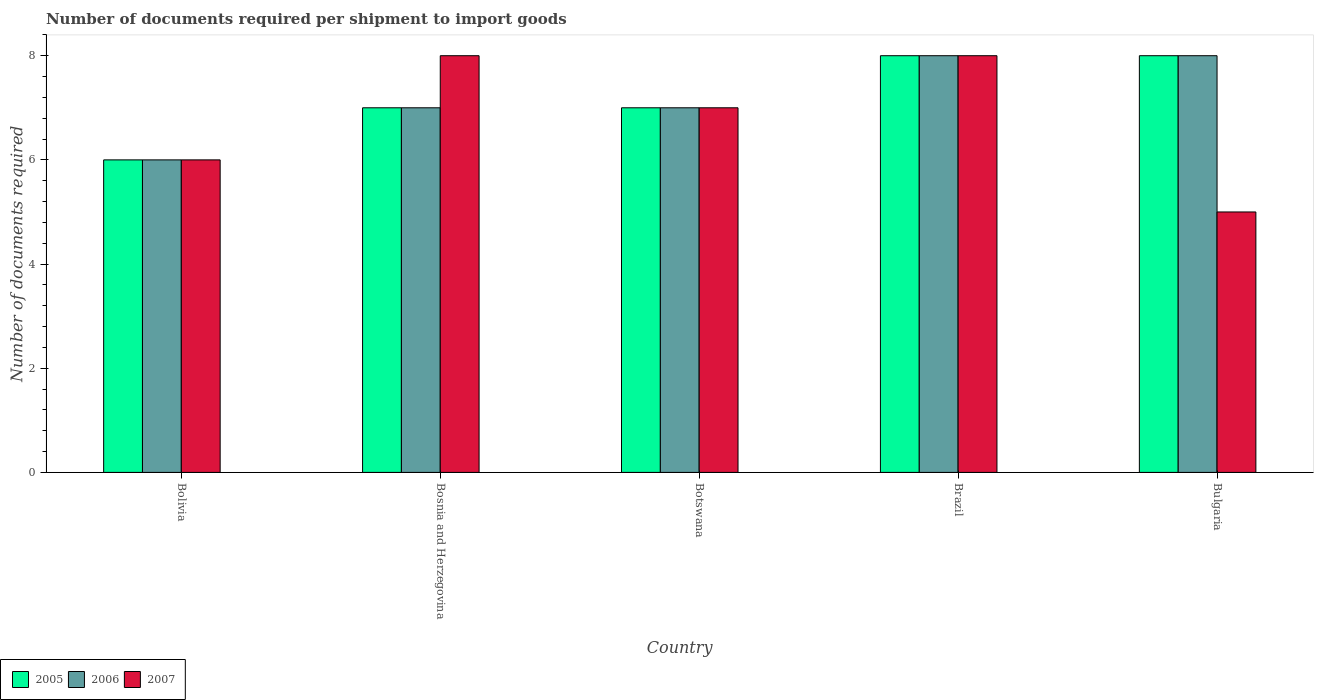How many groups of bars are there?
Keep it short and to the point. 5. Are the number of bars per tick equal to the number of legend labels?
Make the answer very short. Yes. Are the number of bars on each tick of the X-axis equal?
Offer a terse response. Yes. How many bars are there on the 3rd tick from the left?
Ensure brevity in your answer.  3. How many bars are there on the 2nd tick from the right?
Make the answer very short. 3. What is the label of the 1st group of bars from the left?
Offer a very short reply. Bolivia. Across all countries, what is the maximum number of documents required per shipment to import goods in 2005?
Keep it short and to the point. 8. In which country was the number of documents required per shipment to import goods in 2007 minimum?
Ensure brevity in your answer.  Bulgaria. What is the total number of documents required per shipment to import goods in 2006 in the graph?
Your answer should be compact. 36. What is the average number of documents required per shipment to import goods in 2007 per country?
Provide a short and direct response. 6.8. What is the difference between the number of documents required per shipment to import goods of/in 2007 and number of documents required per shipment to import goods of/in 2005 in Brazil?
Provide a succinct answer. 0. In how many countries, is the number of documents required per shipment to import goods in 2006 greater than 2?
Make the answer very short. 5. What is the ratio of the number of documents required per shipment to import goods in 2006 in Bolivia to that in Brazil?
Ensure brevity in your answer.  0.75. Is the sum of the number of documents required per shipment to import goods in 2006 in Brazil and Bulgaria greater than the maximum number of documents required per shipment to import goods in 2005 across all countries?
Your answer should be very brief. Yes. Are all the bars in the graph horizontal?
Provide a succinct answer. No. Does the graph contain any zero values?
Provide a succinct answer. No. What is the title of the graph?
Keep it short and to the point. Number of documents required per shipment to import goods. What is the label or title of the Y-axis?
Your response must be concise. Number of documents required. What is the Number of documents required in 2005 in Bolivia?
Provide a short and direct response. 6. What is the Number of documents required of 2006 in Bolivia?
Offer a terse response. 6. What is the Number of documents required in 2007 in Bolivia?
Make the answer very short. 6. What is the Number of documents required in 2005 in Bosnia and Herzegovina?
Make the answer very short. 7. What is the Number of documents required in 2007 in Bosnia and Herzegovina?
Keep it short and to the point. 8. What is the Number of documents required in 2005 in Botswana?
Make the answer very short. 7. What is the Number of documents required in 2006 in Botswana?
Ensure brevity in your answer.  7. What is the Number of documents required in 2005 in Brazil?
Your response must be concise. 8. What is the Number of documents required in 2007 in Brazil?
Provide a short and direct response. 8. Across all countries, what is the maximum Number of documents required of 2005?
Offer a very short reply. 8. Across all countries, what is the maximum Number of documents required in 2007?
Keep it short and to the point. 8. Across all countries, what is the minimum Number of documents required in 2005?
Give a very brief answer. 6. Across all countries, what is the minimum Number of documents required of 2006?
Ensure brevity in your answer.  6. What is the total Number of documents required of 2005 in the graph?
Give a very brief answer. 36. What is the total Number of documents required in 2007 in the graph?
Your answer should be very brief. 34. What is the difference between the Number of documents required in 2005 in Bolivia and that in Bosnia and Herzegovina?
Your answer should be very brief. -1. What is the difference between the Number of documents required in 2007 in Bolivia and that in Bosnia and Herzegovina?
Make the answer very short. -2. What is the difference between the Number of documents required in 2005 in Bolivia and that in Botswana?
Your answer should be very brief. -1. What is the difference between the Number of documents required in 2006 in Bolivia and that in Botswana?
Offer a terse response. -1. What is the difference between the Number of documents required in 2006 in Bolivia and that in Brazil?
Keep it short and to the point. -2. What is the difference between the Number of documents required of 2007 in Bolivia and that in Brazil?
Make the answer very short. -2. What is the difference between the Number of documents required in 2006 in Bolivia and that in Bulgaria?
Your answer should be very brief. -2. What is the difference between the Number of documents required in 2007 in Bolivia and that in Bulgaria?
Your answer should be compact. 1. What is the difference between the Number of documents required of 2005 in Bosnia and Herzegovina and that in Botswana?
Keep it short and to the point. 0. What is the difference between the Number of documents required of 2006 in Bosnia and Herzegovina and that in Brazil?
Offer a terse response. -1. What is the difference between the Number of documents required in 2007 in Bosnia and Herzegovina and that in Brazil?
Provide a short and direct response. 0. What is the difference between the Number of documents required in 2007 in Bosnia and Herzegovina and that in Bulgaria?
Offer a very short reply. 3. What is the difference between the Number of documents required of 2006 in Botswana and that in Brazil?
Give a very brief answer. -1. What is the difference between the Number of documents required of 2006 in Botswana and that in Bulgaria?
Keep it short and to the point. -1. What is the difference between the Number of documents required of 2007 in Botswana and that in Bulgaria?
Offer a terse response. 2. What is the difference between the Number of documents required of 2005 in Brazil and that in Bulgaria?
Make the answer very short. 0. What is the difference between the Number of documents required of 2006 in Brazil and that in Bulgaria?
Offer a terse response. 0. What is the difference between the Number of documents required in 2006 in Bolivia and the Number of documents required in 2007 in Bosnia and Herzegovina?
Keep it short and to the point. -2. What is the difference between the Number of documents required of 2005 in Bolivia and the Number of documents required of 2006 in Botswana?
Your response must be concise. -1. What is the difference between the Number of documents required of 2005 in Bolivia and the Number of documents required of 2007 in Botswana?
Keep it short and to the point. -1. What is the difference between the Number of documents required in 2006 in Bolivia and the Number of documents required in 2007 in Botswana?
Your answer should be compact. -1. What is the difference between the Number of documents required of 2005 in Bolivia and the Number of documents required of 2007 in Brazil?
Give a very brief answer. -2. What is the difference between the Number of documents required of 2006 in Bolivia and the Number of documents required of 2007 in Brazil?
Your response must be concise. -2. What is the difference between the Number of documents required in 2005 in Bosnia and Herzegovina and the Number of documents required in 2006 in Botswana?
Provide a short and direct response. 0. What is the difference between the Number of documents required in 2005 in Bosnia and Herzegovina and the Number of documents required in 2007 in Botswana?
Your answer should be very brief. 0. What is the difference between the Number of documents required of 2005 in Bosnia and Herzegovina and the Number of documents required of 2007 in Brazil?
Ensure brevity in your answer.  -1. What is the difference between the Number of documents required in 2006 in Bosnia and Herzegovina and the Number of documents required in 2007 in Brazil?
Make the answer very short. -1. What is the difference between the Number of documents required of 2005 in Bosnia and Herzegovina and the Number of documents required of 2006 in Bulgaria?
Your response must be concise. -1. What is the difference between the Number of documents required of 2005 in Bosnia and Herzegovina and the Number of documents required of 2007 in Bulgaria?
Your answer should be compact. 2. What is the difference between the Number of documents required of 2006 in Bosnia and Herzegovina and the Number of documents required of 2007 in Bulgaria?
Ensure brevity in your answer.  2. What is the difference between the Number of documents required in 2005 in Botswana and the Number of documents required in 2006 in Brazil?
Keep it short and to the point. -1. What is the difference between the Number of documents required in 2005 in Botswana and the Number of documents required in 2006 in Bulgaria?
Provide a succinct answer. -1. What is the difference between the Number of documents required in 2005 in Botswana and the Number of documents required in 2007 in Bulgaria?
Your response must be concise. 2. What is the difference between the Number of documents required in 2006 in Brazil and the Number of documents required in 2007 in Bulgaria?
Offer a terse response. 3. What is the average Number of documents required of 2006 per country?
Provide a succinct answer. 7.2. What is the average Number of documents required of 2007 per country?
Give a very brief answer. 6.8. What is the difference between the Number of documents required of 2005 and Number of documents required of 2006 in Bolivia?
Offer a terse response. 0. What is the difference between the Number of documents required of 2005 and Number of documents required of 2007 in Bolivia?
Ensure brevity in your answer.  0. What is the difference between the Number of documents required in 2005 and Number of documents required in 2006 in Bosnia and Herzegovina?
Give a very brief answer. 0. What is the difference between the Number of documents required in 2006 and Number of documents required in 2007 in Botswana?
Offer a very short reply. 0. What is the difference between the Number of documents required in 2005 and Number of documents required in 2006 in Brazil?
Make the answer very short. 0. What is the difference between the Number of documents required of 2005 and Number of documents required of 2007 in Brazil?
Your answer should be compact. 0. What is the difference between the Number of documents required in 2006 and Number of documents required in 2007 in Brazil?
Provide a succinct answer. 0. What is the difference between the Number of documents required of 2005 and Number of documents required of 2006 in Bulgaria?
Offer a terse response. 0. What is the difference between the Number of documents required in 2006 and Number of documents required in 2007 in Bulgaria?
Your answer should be very brief. 3. What is the ratio of the Number of documents required in 2006 in Bolivia to that in Bosnia and Herzegovina?
Your response must be concise. 0.86. What is the ratio of the Number of documents required of 2005 in Bosnia and Herzegovina to that in Botswana?
Offer a very short reply. 1. What is the ratio of the Number of documents required of 2007 in Bosnia and Herzegovina to that in Botswana?
Ensure brevity in your answer.  1.14. What is the ratio of the Number of documents required of 2005 in Bosnia and Herzegovina to that in Brazil?
Your answer should be compact. 0.88. What is the ratio of the Number of documents required of 2006 in Bosnia and Herzegovina to that in Brazil?
Provide a short and direct response. 0.88. What is the ratio of the Number of documents required in 2007 in Bosnia and Herzegovina to that in Brazil?
Your answer should be very brief. 1. What is the ratio of the Number of documents required of 2005 in Bosnia and Herzegovina to that in Bulgaria?
Your response must be concise. 0.88. What is the ratio of the Number of documents required in 2006 in Bosnia and Herzegovina to that in Bulgaria?
Offer a very short reply. 0.88. What is the ratio of the Number of documents required of 2005 in Botswana to that in Brazil?
Provide a succinct answer. 0.88. What is the ratio of the Number of documents required in 2006 in Botswana to that in Brazil?
Ensure brevity in your answer.  0.88. What is the ratio of the Number of documents required of 2007 in Botswana to that in Brazil?
Offer a terse response. 0.88. What is the ratio of the Number of documents required in 2005 in Botswana to that in Bulgaria?
Ensure brevity in your answer.  0.88. What is the ratio of the Number of documents required of 2006 in Botswana to that in Bulgaria?
Make the answer very short. 0.88. What is the ratio of the Number of documents required of 2007 in Botswana to that in Bulgaria?
Give a very brief answer. 1.4. What is the ratio of the Number of documents required of 2005 in Brazil to that in Bulgaria?
Ensure brevity in your answer.  1. What is the difference between the highest and the second highest Number of documents required in 2005?
Your answer should be compact. 0. What is the difference between the highest and the second highest Number of documents required of 2007?
Your answer should be very brief. 0. What is the difference between the highest and the lowest Number of documents required in 2005?
Your answer should be compact. 2. What is the difference between the highest and the lowest Number of documents required of 2006?
Give a very brief answer. 2. What is the difference between the highest and the lowest Number of documents required in 2007?
Provide a short and direct response. 3. 